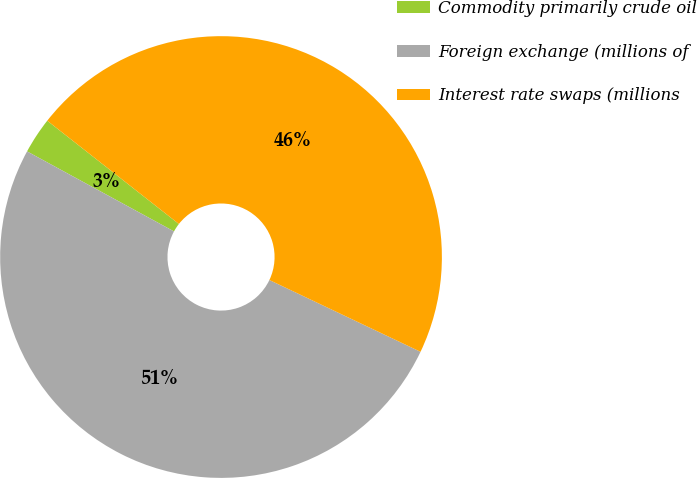<chart> <loc_0><loc_0><loc_500><loc_500><pie_chart><fcel>Commodity primarily crude oil<fcel>Foreign exchange (millions of<fcel>Interest rate swaps (millions<nl><fcel>2.65%<fcel>50.88%<fcel>46.47%<nl></chart> 